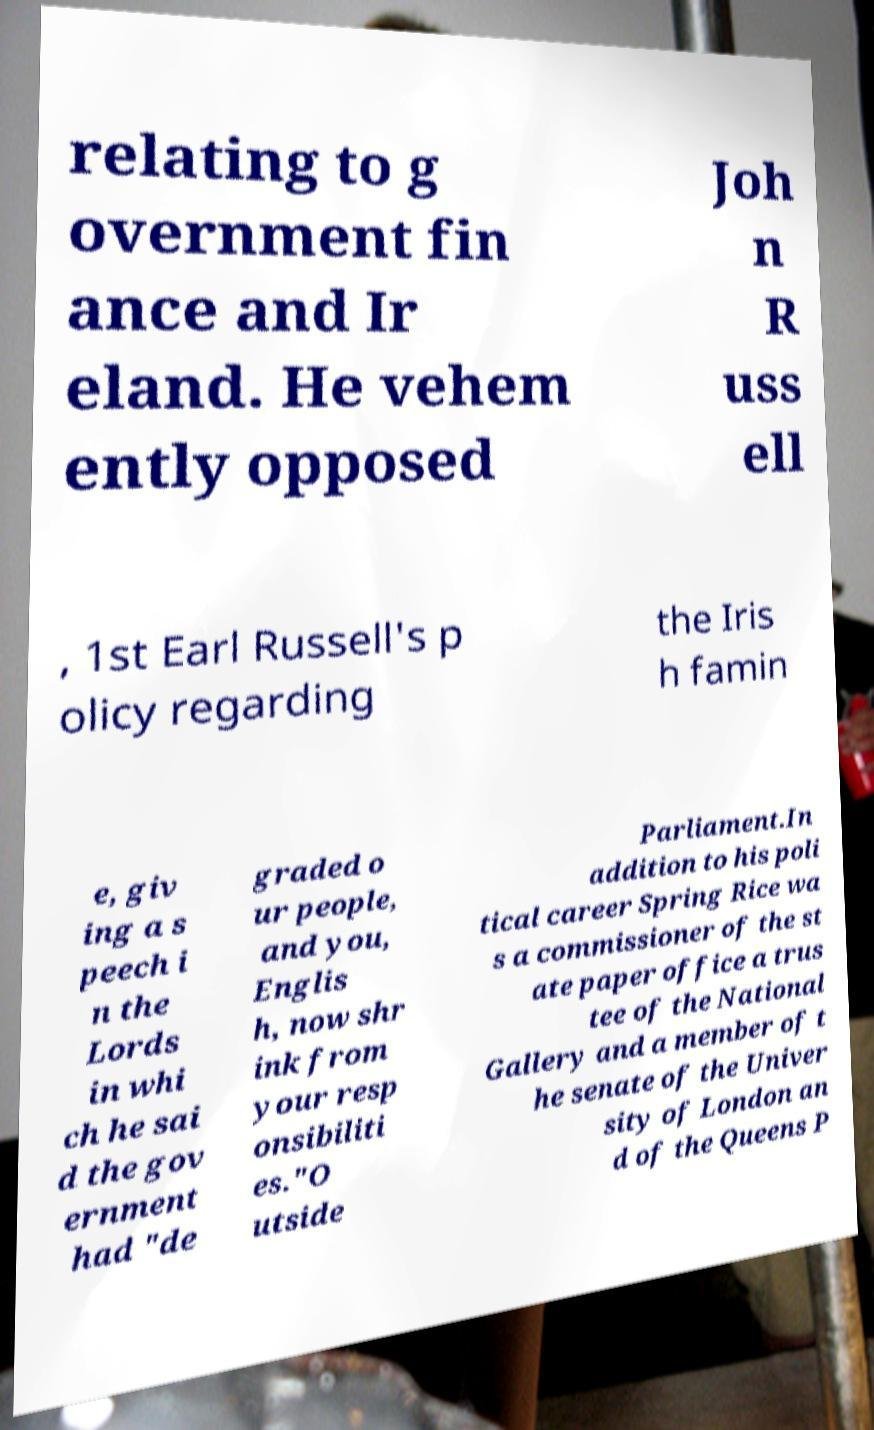Please identify and transcribe the text found in this image. relating to g overnment fin ance and Ir eland. He vehem ently opposed Joh n R uss ell , 1st Earl Russell's p olicy regarding the Iris h famin e, giv ing a s peech i n the Lords in whi ch he sai d the gov ernment had "de graded o ur people, and you, Englis h, now shr ink from your resp onsibiliti es."O utside Parliament.In addition to his poli tical career Spring Rice wa s a commissioner of the st ate paper office a trus tee of the National Gallery and a member of t he senate of the Univer sity of London an d of the Queens P 